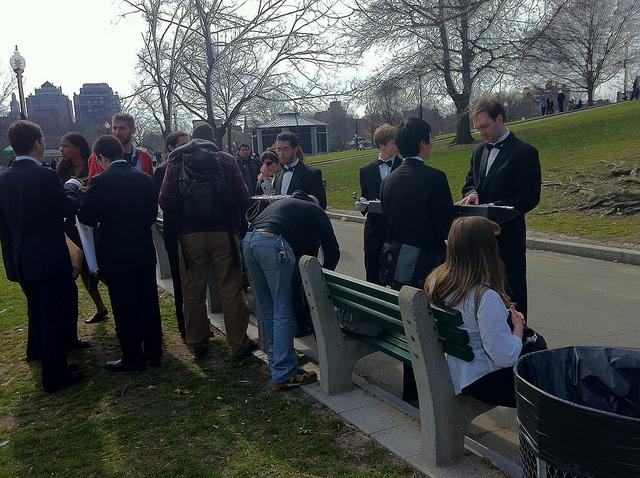What does the man farthest to the right have on his neck?

Choices:
A) scarf
B) hands
C) goggles
D) bowtie bowtie 